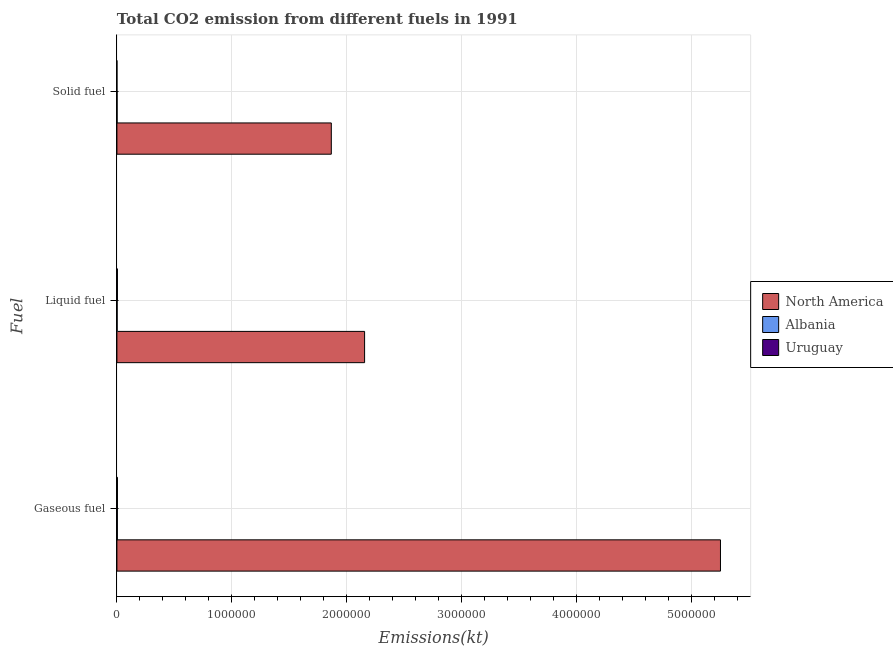How many different coloured bars are there?
Your response must be concise. 3. Are the number of bars per tick equal to the number of legend labels?
Offer a terse response. Yes. Are the number of bars on each tick of the Y-axis equal?
Your answer should be compact. Yes. What is the label of the 3rd group of bars from the top?
Ensure brevity in your answer.  Gaseous fuel. What is the amount of co2 emissions from gaseous fuel in Uruguay?
Your answer should be very brief. 4554.41. Across all countries, what is the maximum amount of co2 emissions from gaseous fuel?
Offer a terse response. 5.25e+06. Across all countries, what is the minimum amount of co2 emissions from gaseous fuel?
Offer a very short reply. 3971.36. In which country was the amount of co2 emissions from liquid fuel minimum?
Offer a very short reply. Albania. What is the total amount of co2 emissions from liquid fuel in the graph?
Your answer should be compact. 2.16e+06. What is the difference between the amount of co2 emissions from liquid fuel in Uruguay and that in Albania?
Give a very brief answer. 2390.88. What is the difference between the amount of co2 emissions from solid fuel in Uruguay and the amount of co2 emissions from liquid fuel in North America?
Your response must be concise. -2.15e+06. What is the average amount of co2 emissions from gaseous fuel per country?
Your answer should be very brief. 1.75e+06. What is the difference between the amount of co2 emissions from solid fuel and amount of co2 emissions from liquid fuel in Albania?
Your answer should be compact. -432.71. What is the ratio of the amount of co2 emissions from solid fuel in Uruguay to that in North America?
Your answer should be compact. 1.9665252106338232e-6. Is the difference between the amount of co2 emissions from solid fuel in North America and Uruguay greater than the difference between the amount of co2 emissions from liquid fuel in North America and Uruguay?
Your answer should be very brief. No. What is the difference between the highest and the second highest amount of co2 emissions from solid fuel?
Your answer should be very brief. 1.86e+06. What is the difference between the highest and the lowest amount of co2 emissions from gaseous fuel?
Provide a succinct answer. 5.25e+06. In how many countries, is the amount of co2 emissions from solid fuel greater than the average amount of co2 emissions from solid fuel taken over all countries?
Your response must be concise. 1. Is the sum of the amount of co2 emissions from liquid fuel in Albania and North America greater than the maximum amount of co2 emissions from solid fuel across all countries?
Ensure brevity in your answer.  Yes. What does the 2nd bar from the top in Liquid fuel represents?
Offer a terse response. Albania. What does the 3rd bar from the bottom in Solid fuel represents?
Your answer should be compact. Uruguay. How many bars are there?
Provide a short and direct response. 9. How many countries are there in the graph?
Offer a terse response. 3. What is the difference between two consecutive major ticks on the X-axis?
Offer a terse response. 1.00e+06. Are the values on the major ticks of X-axis written in scientific E-notation?
Your answer should be very brief. No. Does the graph contain grids?
Provide a succinct answer. Yes. How many legend labels are there?
Make the answer very short. 3. What is the title of the graph?
Make the answer very short. Total CO2 emission from different fuels in 1991. Does "Swaziland" appear as one of the legend labels in the graph?
Offer a very short reply. No. What is the label or title of the X-axis?
Offer a terse response. Emissions(kt). What is the label or title of the Y-axis?
Ensure brevity in your answer.  Fuel. What is the Emissions(kt) of North America in Gaseous fuel?
Your answer should be compact. 5.25e+06. What is the Emissions(kt) in Albania in Gaseous fuel?
Your answer should be compact. 3971.36. What is the Emissions(kt) in Uruguay in Gaseous fuel?
Provide a short and direct response. 4554.41. What is the Emissions(kt) of North America in Liquid fuel?
Ensure brevity in your answer.  2.15e+06. What is the Emissions(kt) of Albania in Liquid fuel?
Your answer should be compact. 1914.17. What is the Emissions(kt) in Uruguay in Liquid fuel?
Provide a succinct answer. 4305.06. What is the Emissions(kt) in North America in Solid fuel?
Keep it short and to the point. 1.86e+06. What is the Emissions(kt) of Albania in Solid fuel?
Keep it short and to the point. 1481.47. What is the Emissions(kt) in Uruguay in Solid fuel?
Your response must be concise. 3.67. Across all Fuel, what is the maximum Emissions(kt) of North America?
Offer a terse response. 5.25e+06. Across all Fuel, what is the maximum Emissions(kt) in Albania?
Your answer should be compact. 3971.36. Across all Fuel, what is the maximum Emissions(kt) of Uruguay?
Offer a very short reply. 4554.41. Across all Fuel, what is the minimum Emissions(kt) of North America?
Give a very brief answer. 1.86e+06. Across all Fuel, what is the minimum Emissions(kt) in Albania?
Give a very brief answer. 1481.47. Across all Fuel, what is the minimum Emissions(kt) of Uruguay?
Provide a succinct answer. 3.67. What is the total Emissions(kt) of North America in the graph?
Keep it short and to the point. 9.27e+06. What is the total Emissions(kt) of Albania in the graph?
Your answer should be very brief. 7367. What is the total Emissions(kt) of Uruguay in the graph?
Ensure brevity in your answer.  8863.14. What is the difference between the Emissions(kt) in North America in Gaseous fuel and that in Liquid fuel?
Make the answer very short. 3.10e+06. What is the difference between the Emissions(kt) of Albania in Gaseous fuel and that in Liquid fuel?
Offer a very short reply. 2057.19. What is the difference between the Emissions(kt) of Uruguay in Gaseous fuel and that in Liquid fuel?
Offer a terse response. 249.36. What is the difference between the Emissions(kt) of North America in Gaseous fuel and that in Solid fuel?
Offer a terse response. 3.38e+06. What is the difference between the Emissions(kt) in Albania in Gaseous fuel and that in Solid fuel?
Your response must be concise. 2489.89. What is the difference between the Emissions(kt) in Uruguay in Gaseous fuel and that in Solid fuel?
Your answer should be very brief. 4550.75. What is the difference between the Emissions(kt) in North America in Liquid fuel and that in Solid fuel?
Your answer should be compact. 2.90e+05. What is the difference between the Emissions(kt) in Albania in Liquid fuel and that in Solid fuel?
Offer a very short reply. 432.71. What is the difference between the Emissions(kt) in Uruguay in Liquid fuel and that in Solid fuel?
Provide a succinct answer. 4301.39. What is the difference between the Emissions(kt) of North America in Gaseous fuel and the Emissions(kt) of Albania in Liquid fuel?
Give a very brief answer. 5.25e+06. What is the difference between the Emissions(kt) in North America in Gaseous fuel and the Emissions(kt) in Uruguay in Liquid fuel?
Your answer should be compact. 5.25e+06. What is the difference between the Emissions(kt) in Albania in Gaseous fuel and the Emissions(kt) in Uruguay in Liquid fuel?
Ensure brevity in your answer.  -333.7. What is the difference between the Emissions(kt) of North America in Gaseous fuel and the Emissions(kt) of Albania in Solid fuel?
Provide a succinct answer. 5.25e+06. What is the difference between the Emissions(kt) in North America in Gaseous fuel and the Emissions(kt) in Uruguay in Solid fuel?
Provide a short and direct response. 5.25e+06. What is the difference between the Emissions(kt) of Albania in Gaseous fuel and the Emissions(kt) of Uruguay in Solid fuel?
Make the answer very short. 3967.69. What is the difference between the Emissions(kt) of North America in Liquid fuel and the Emissions(kt) of Albania in Solid fuel?
Your response must be concise. 2.15e+06. What is the difference between the Emissions(kt) of North America in Liquid fuel and the Emissions(kt) of Uruguay in Solid fuel?
Give a very brief answer. 2.15e+06. What is the difference between the Emissions(kt) in Albania in Liquid fuel and the Emissions(kt) in Uruguay in Solid fuel?
Your response must be concise. 1910.51. What is the average Emissions(kt) in North America per Fuel?
Give a very brief answer. 3.09e+06. What is the average Emissions(kt) of Albania per Fuel?
Make the answer very short. 2455.67. What is the average Emissions(kt) in Uruguay per Fuel?
Keep it short and to the point. 2954.38. What is the difference between the Emissions(kt) in North America and Emissions(kt) in Albania in Gaseous fuel?
Make the answer very short. 5.25e+06. What is the difference between the Emissions(kt) in North America and Emissions(kt) in Uruguay in Gaseous fuel?
Offer a terse response. 5.25e+06. What is the difference between the Emissions(kt) of Albania and Emissions(kt) of Uruguay in Gaseous fuel?
Make the answer very short. -583.05. What is the difference between the Emissions(kt) in North America and Emissions(kt) in Albania in Liquid fuel?
Keep it short and to the point. 2.15e+06. What is the difference between the Emissions(kt) of North America and Emissions(kt) of Uruguay in Liquid fuel?
Your response must be concise. 2.15e+06. What is the difference between the Emissions(kt) of Albania and Emissions(kt) of Uruguay in Liquid fuel?
Make the answer very short. -2390.88. What is the difference between the Emissions(kt) of North America and Emissions(kt) of Albania in Solid fuel?
Provide a short and direct response. 1.86e+06. What is the difference between the Emissions(kt) in North America and Emissions(kt) in Uruguay in Solid fuel?
Keep it short and to the point. 1.86e+06. What is the difference between the Emissions(kt) in Albania and Emissions(kt) in Uruguay in Solid fuel?
Ensure brevity in your answer.  1477.8. What is the ratio of the Emissions(kt) of North America in Gaseous fuel to that in Liquid fuel?
Offer a terse response. 2.44. What is the ratio of the Emissions(kt) of Albania in Gaseous fuel to that in Liquid fuel?
Your answer should be very brief. 2.07. What is the ratio of the Emissions(kt) of Uruguay in Gaseous fuel to that in Liquid fuel?
Offer a very short reply. 1.06. What is the ratio of the Emissions(kt) of North America in Gaseous fuel to that in Solid fuel?
Ensure brevity in your answer.  2.82. What is the ratio of the Emissions(kt) of Albania in Gaseous fuel to that in Solid fuel?
Your answer should be compact. 2.68. What is the ratio of the Emissions(kt) in Uruguay in Gaseous fuel to that in Solid fuel?
Your answer should be very brief. 1242. What is the ratio of the Emissions(kt) of North America in Liquid fuel to that in Solid fuel?
Offer a very short reply. 1.16. What is the ratio of the Emissions(kt) in Albania in Liquid fuel to that in Solid fuel?
Give a very brief answer. 1.29. What is the ratio of the Emissions(kt) of Uruguay in Liquid fuel to that in Solid fuel?
Your answer should be compact. 1174. What is the difference between the highest and the second highest Emissions(kt) of North America?
Your answer should be very brief. 3.10e+06. What is the difference between the highest and the second highest Emissions(kt) in Albania?
Your response must be concise. 2057.19. What is the difference between the highest and the second highest Emissions(kt) of Uruguay?
Ensure brevity in your answer.  249.36. What is the difference between the highest and the lowest Emissions(kt) in North America?
Your answer should be very brief. 3.38e+06. What is the difference between the highest and the lowest Emissions(kt) in Albania?
Make the answer very short. 2489.89. What is the difference between the highest and the lowest Emissions(kt) of Uruguay?
Offer a very short reply. 4550.75. 